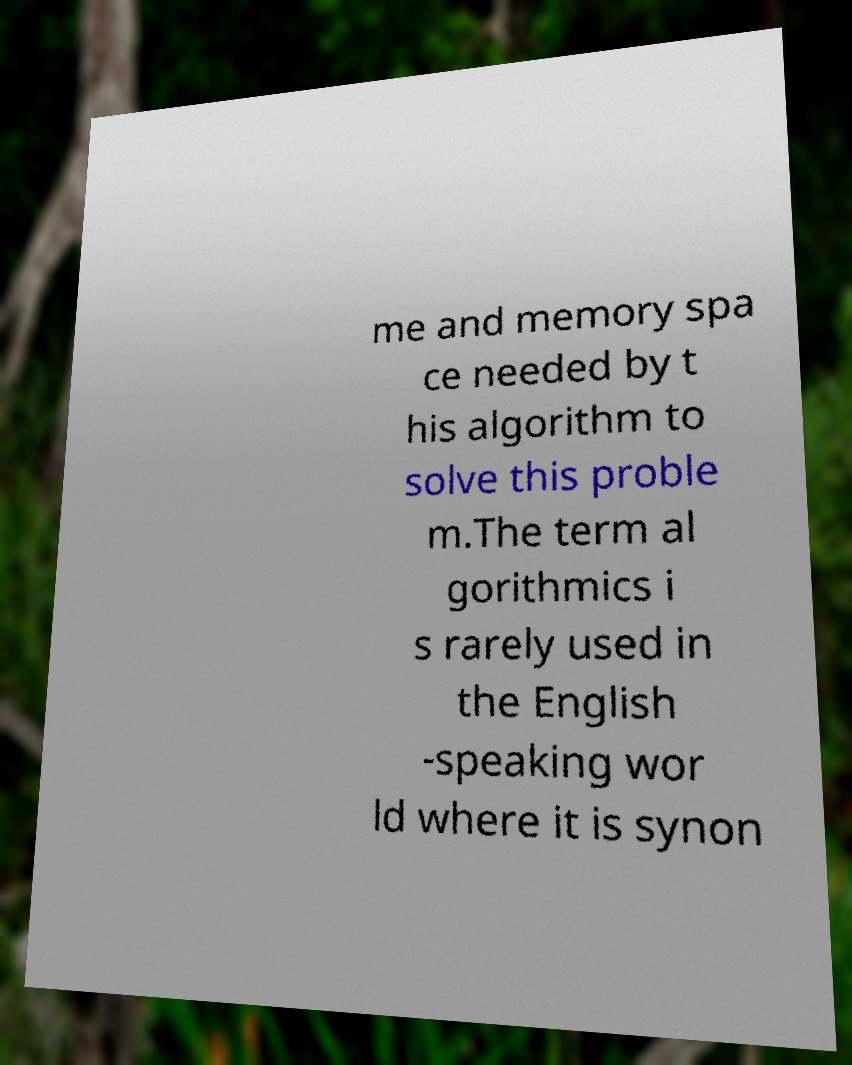Please identify and transcribe the text found in this image. me and memory spa ce needed by t his algorithm to solve this proble m.The term al gorithmics i s rarely used in the English -speaking wor ld where it is synon 